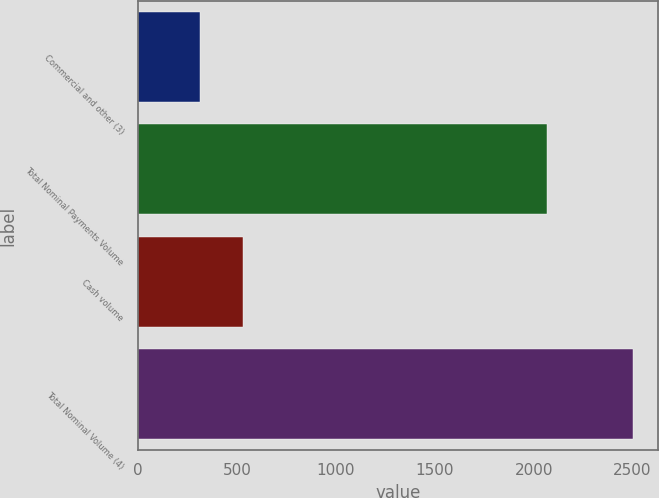Convert chart. <chart><loc_0><loc_0><loc_500><loc_500><bar_chart><fcel>Commercial and other (3)<fcel>Total Nominal Payments Volume<fcel>Cash volume<fcel>Total Nominal Volume (4)<nl><fcel>311<fcel>2066<fcel>530.2<fcel>2503<nl></chart> 